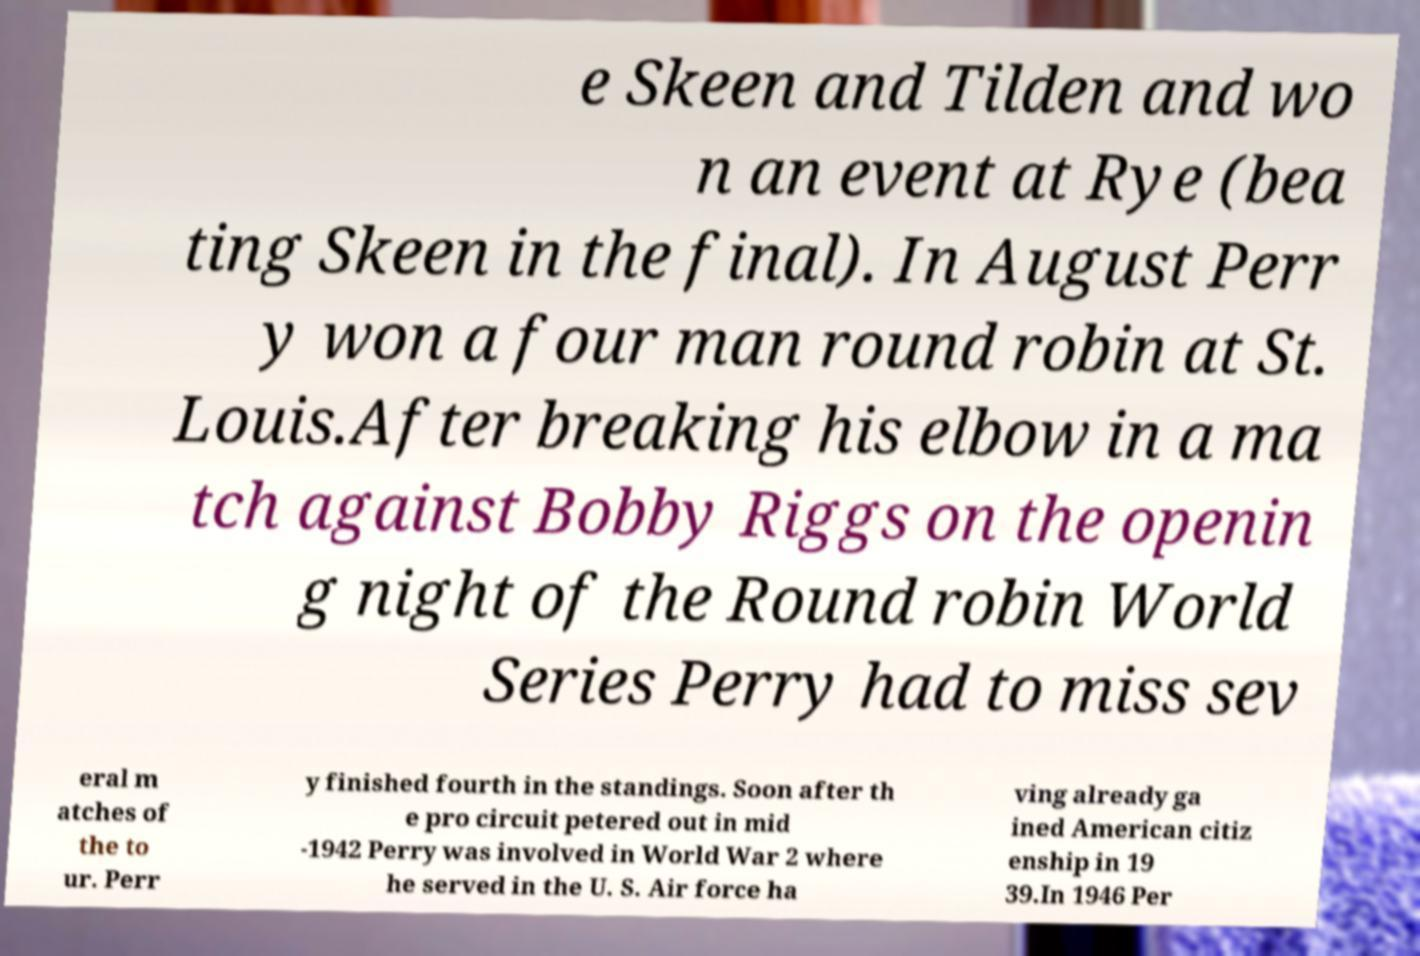What messages or text are displayed in this image? I need them in a readable, typed format. e Skeen and Tilden and wo n an event at Rye (bea ting Skeen in the final). In August Perr y won a four man round robin at St. Louis.After breaking his elbow in a ma tch against Bobby Riggs on the openin g night of the Round robin World Series Perry had to miss sev eral m atches of the to ur. Perr y finished fourth in the standings. Soon after th e pro circuit petered out in mid -1942 Perry was involved in World War 2 where he served in the U. S. Air force ha ving already ga ined American citiz enship in 19 39.In 1946 Per 